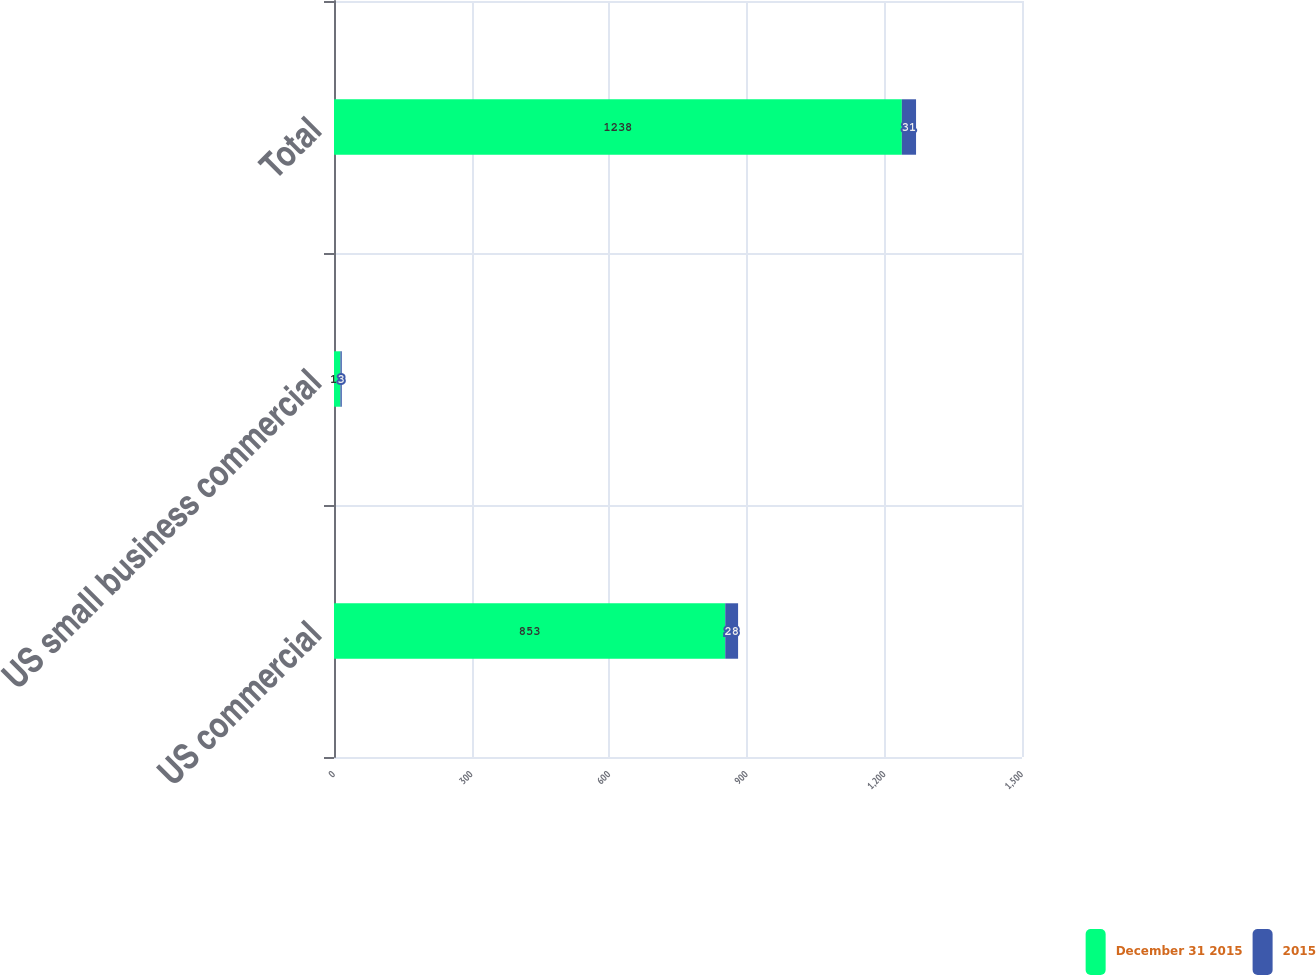<chart> <loc_0><loc_0><loc_500><loc_500><stacked_bar_chart><ecel><fcel>US commercial<fcel>US small business commercial<fcel>Total<nl><fcel>December 31 2015<fcel>853<fcel>14<fcel>1238<nl><fcel>2015<fcel>28<fcel>3<fcel>31<nl></chart> 